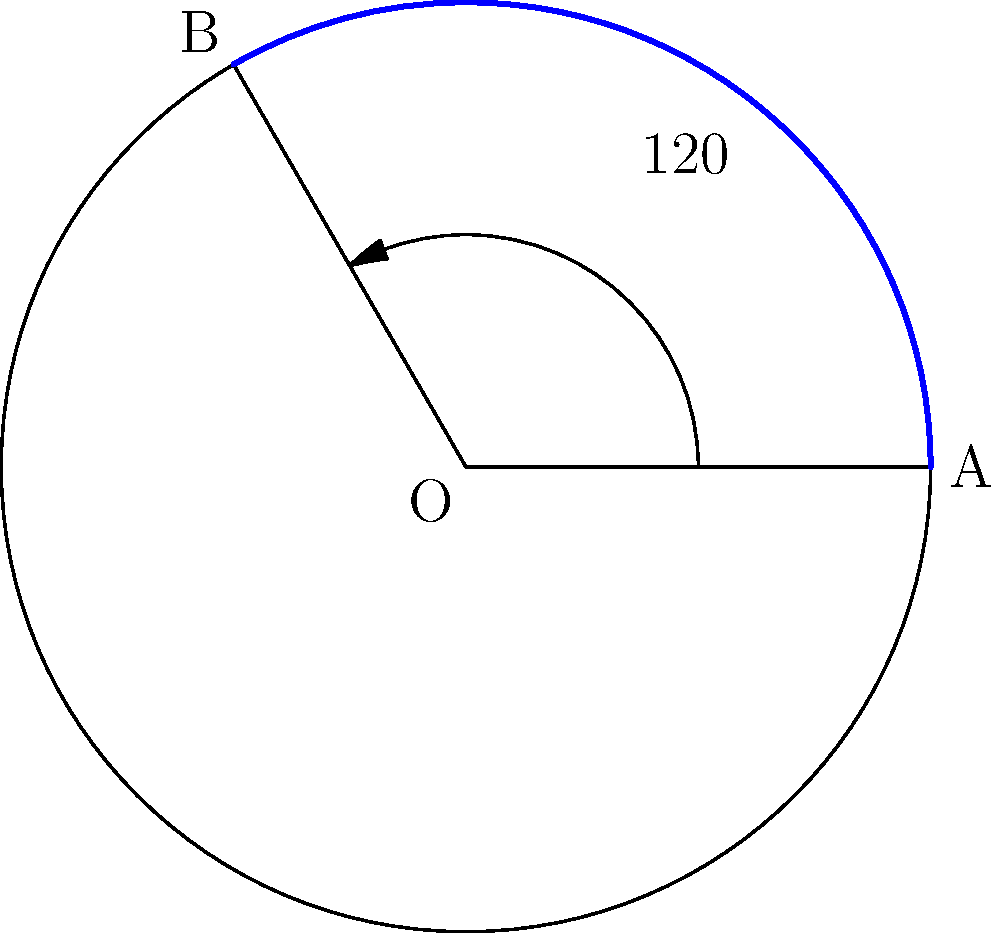A patient's range of motion after shoulder surgery is represented by an arc on a circle with a radius of 15 cm. If the central angle of this arc is 120°, what is the length of the arc representing the patient's range of motion? To solve this problem, we'll follow these steps:

1) Recall the formula for arc length:
   Arc length = $\frac{\theta}{360°} \cdot 2\pi r$
   where $\theta$ is the central angle in degrees and $r$ is the radius.

2) We're given:
   - Radius (r) = 15 cm
   - Central angle ($\theta$) = 120°

3) Let's substitute these values into our formula:
   Arc length = $\frac{120°}{360°} \cdot 2\pi \cdot 15$ cm

4) Simplify:
   Arc length = $\frac{1}{3} \cdot 2\pi \cdot 15$ cm
               = $\frac{1}{3} \cdot 30\pi$ cm
               = $10\pi$ cm

5) To get a decimal approximation:
   Arc length ≈ 31.42 cm

Therefore, the length of the arc representing the patient's range of motion is $10\pi$ cm or approximately 31.42 cm.
Answer: $10\pi$ cm 